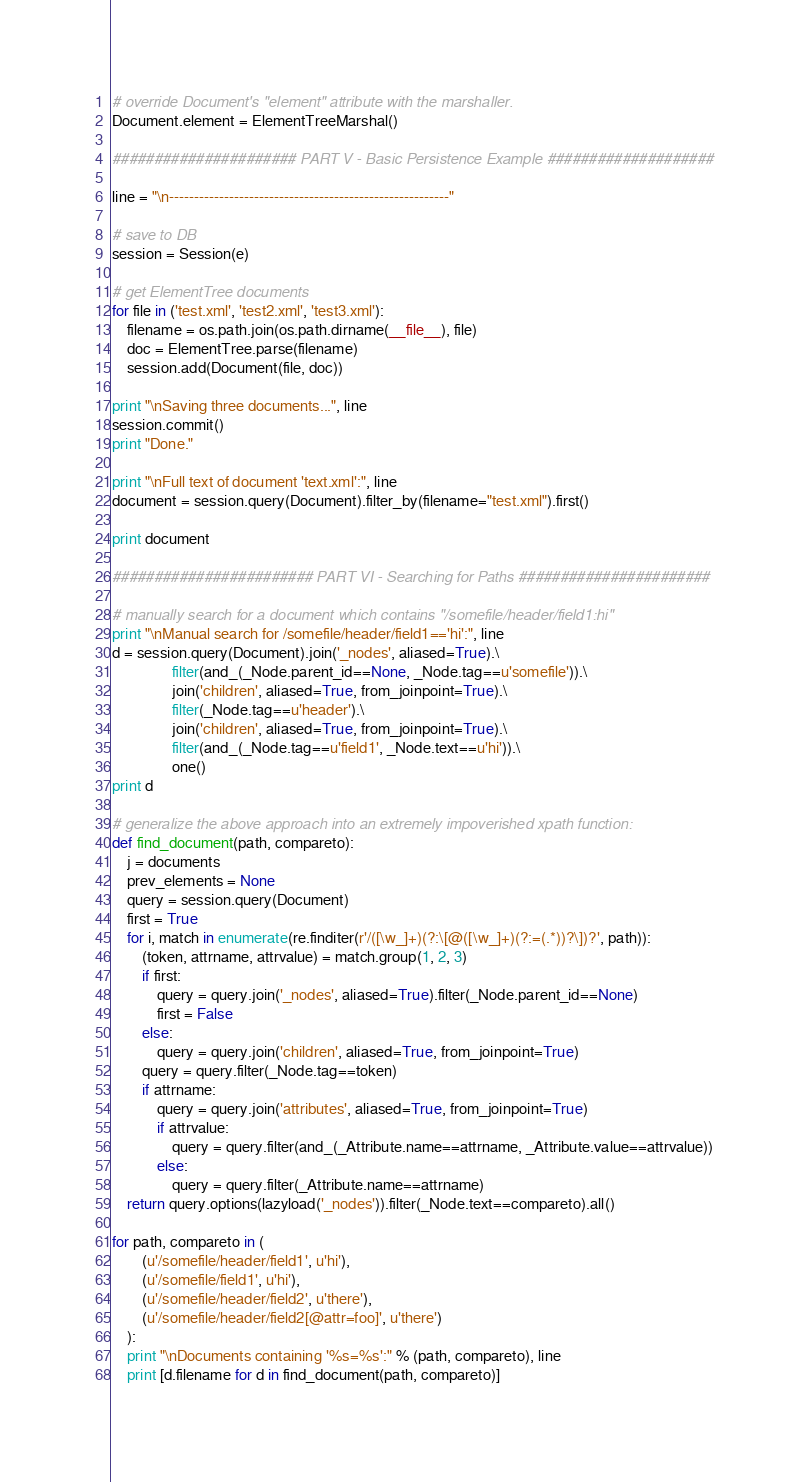Convert code to text. <code><loc_0><loc_0><loc_500><loc_500><_Python_># override Document's "element" attribute with the marshaller.
Document.element = ElementTreeMarshal()

###################### PART V - Basic Persistence Example ####################

line = "\n--------------------------------------------------------"

# save to DB
session = Session(e)

# get ElementTree documents
for file in ('test.xml', 'test2.xml', 'test3.xml'):
    filename = os.path.join(os.path.dirname(__file__), file)
    doc = ElementTree.parse(filename)
    session.add(Document(file, doc))

print "\nSaving three documents...", line
session.commit()
print "Done."

print "\nFull text of document 'text.xml':", line
document = session.query(Document).filter_by(filename="test.xml").first()

print document

######################## PART VI - Searching for Paths #######################

# manually search for a document which contains "/somefile/header/field1:hi"
print "\nManual search for /somefile/header/field1=='hi':", line
d = session.query(Document).join('_nodes', aliased=True).\
                filter(and_(_Node.parent_id==None, _Node.tag==u'somefile')).\
                join('children', aliased=True, from_joinpoint=True).\
                filter(_Node.tag==u'header').\
                join('children', aliased=True, from_joinpoint=True).\
                filter(and_(_Node.tag==u'field1', _Node.text==u'hi')).\
                one()
print d

# generalize the above approach into an extremely impoverished xpath function:
def find_document(path, compareto):
    j = documents
    prev_elements = None
    query = session.query(Document)
    first = True
    for i, match in enumerate(re.finditer(r'/([\w_]+)(?:\[@([\w_]+)(?:=(.*))?\])?', path)):
        (token, attrname, attrvalue) = match.group(1, 2, 3)
        if first:
            query = query.join('_nodes', aliased=True).filter(_Node.parent_id==None)
            first = False
        else:
            query = query.join('children', aliased=True, from_joinpoint=True)
        query = query.filter(_Node.tag==token)
        if attrname:
            query = query.join('attributes', aliased=True, from_joinpoint=True)
            if attrvalue:
                query = query.filter(and_(_Attribute.name==attrname, _Attribute.value==attrvalue))
            else:
                query = query.filter(_Attribute.name==attrname)
    return query.options(lazyload('_nodes')).filter(_Node.text==compareto).all()

for path, compareto in (
        (u'/somefile/header/field1', u'hi'),
        (u'/somefile/field1', u'hi'),
        (u'/somefile/header/field2', u'there'),
        (u'/somefile/header/field2[@attr=foo]', u'there')
    ):
    print "\nDocuments containing '%s=%s':" % (path, compareto), line
    print [d.filename for d in find_document(path, compareto)]

</code> 